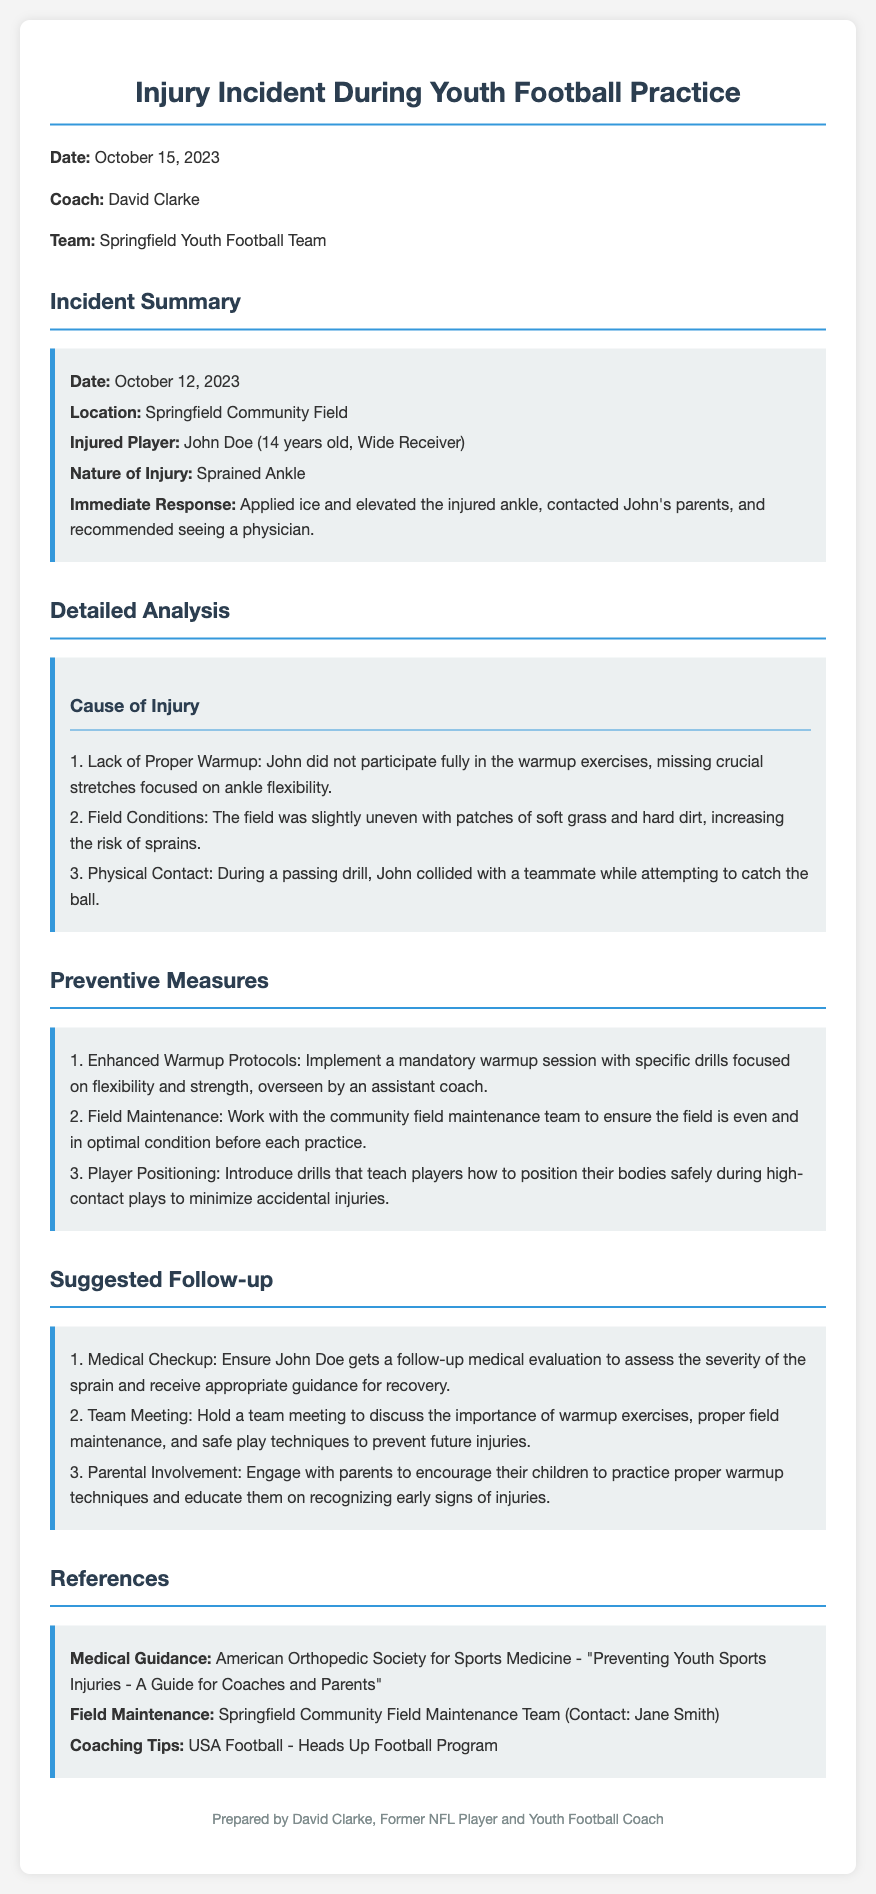What is the date of the incident? The date of the incident is specified in the incident summary section of the document.
Answer: October 12, 2023 Who was the injured player? The name of the injured player is mentioned in the incident summary section.
Answer: John Doe What was the nature of the injury? The type of injury sustained by the player is detailed in the incident summary.
Answer: Sprained Ankle What contributed to the injury according to its cause? Several factors contributing to the injury are listed in the detailed analysis section.
Answer: Lack of Proper Warmup What is one of the suggested preventive measures? The document outlines several preventive measures in its respective section.
Answer: Enhanced Warmup Protocols How old is the injured player? The age of John Doe is included in the incident summary.
Answer: 14 years old Who prepared the document? The author of the report is highlighted at the end of the document.
Answer: David Clarke What should be ensured for John Doe after the injury? The follow-up section specifies the actions recommended after the incident.
Answer: Medical Checkup What is a reference listed for medical guidance? The document provides references for further information regarding injury prevention.
Answer: American Orthopedic Society for Sports Medicine 